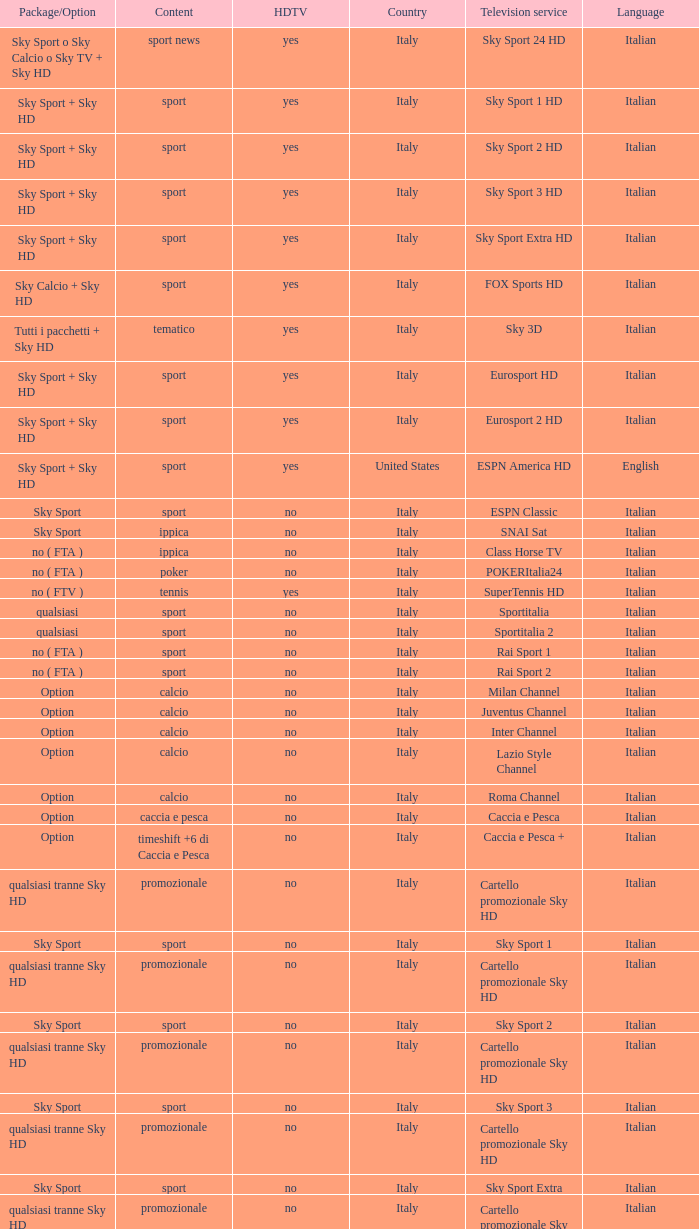What is Package/Option, when Content is Poker? No ( fta ). 